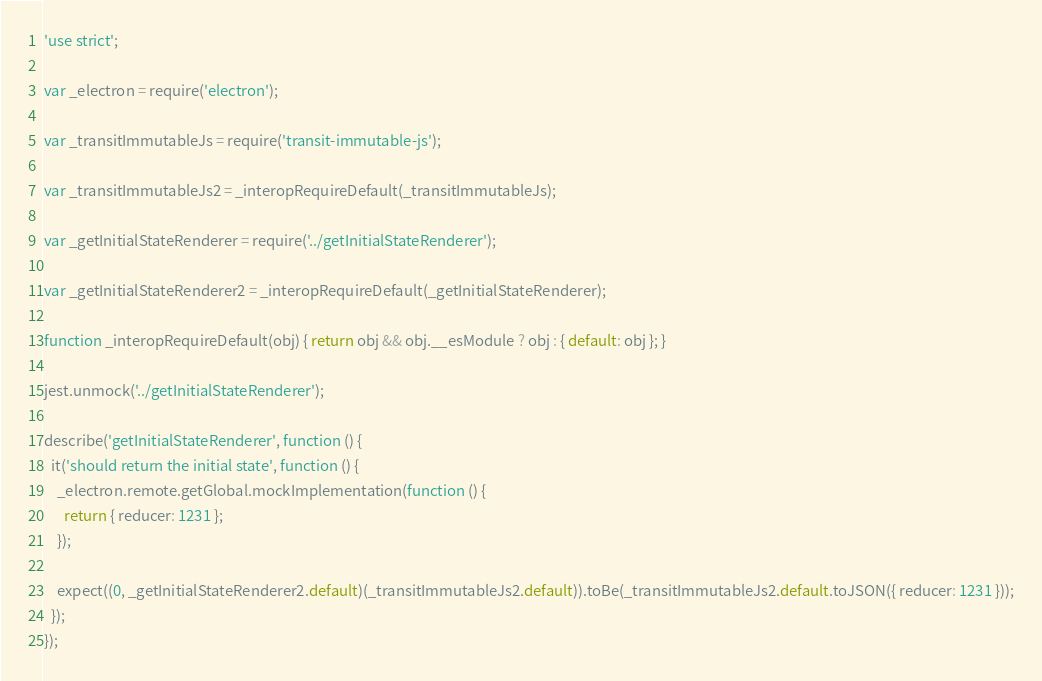Convert code to text. <code><loc_0><loc_0><loc_500><loc_500><_JavaScript_>'use strict';

var _electron = require('electron');

var _transitImmutableJs = require('transit-immutable-js');

var _transitImmutableJs2 = _interopRequireDefault(_transitImmutableJs);

var _getInitialStateRenderer = require('../getInitialStateRenderer');

var _getInitialStateRenderer2 = _interopRequireDefault(_getInitialStateRenderer);

function _interopRequireDefault(obj) { return obj && obj.__esModule ? obj : { default: obj }; }

jest.unmock('../getInitialStateRenderer');

describe('getInitialStateRenderer', function () {
  it('should return the initial state', function () {
    _electron.remote.getGlobal.mockImplementation(function () {
      return { reducer: 1231 };
    });

    expect((0, _getInitialStateRenderer2.default)(_transitImmutableJs2.default)).toBe(_transitImmutableJs2.default.toJSON({ reducer: 1231 }));
  });
});</code> 